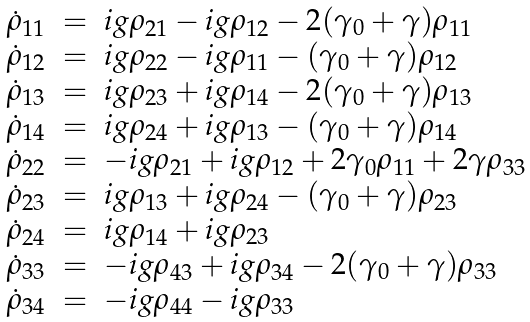<formula> <loc_0><loc_0><loc_500><loc_500>\begin{array} { c c l } \dot { \rho } _ { 1 1 } & = & i g \rho _ { 2 1 } - i g \rho _ { 1 2 } - 2 ( \gamma _ { 0 } + \gamma ) \rho _ { 1 1 } \\ \dot { \rho } _ { 1 2 } & = & i g \rho _ { 2 2 } - i g \rho _ { 1 1 } - ( \gamma _ { 0 } + \gamma ) \rho _ { 1 2 } \\ \dot { \rho } _ { 1 3 } & = & i g \rho _ { 2 3 } + i g \rho _ { 1 4 } - 2 ( \gamma _ { 0 } + \gamma ) \rho _ { 1 3 } \\ \dot { \rho } _ { 1 4 } & = & i g \rho _ { 2 4 } + i g \rho _ { 1 3 } - ( \gamma _ { 0 } + \gamma ) \rho _ { 1 4 } \\ \dot { \rho } _ { 2 2 } & = & - i g \rho _ { 2 1 } + i g \rho _ { 1 2 } + 2 \gamma _ { 0 } \rho _ { 1 1 } + 2 \gamma \rho _ { 3 3 } \\ \dot { \rho } _ { 2 3 } & = & i g \rho _ { 1 3 } + i g \rho _ { 2 4 } - ( \gamma _ { 0 } + \gamma ) \rho _ { 2 3 } \\ \dot { \rho } _ { 2 4 } & = & i g \rho _ { 1 4 } + i g \rho _ { 2 3 } \\ \dot { \rho } _ { 3 3 } & = & - i g \rho _ { 4 3 } + i g \rho _ { 3 4 } - 2 ( \gamma _ { 0 } + \gamma ) \rho _ { 3 3 } \\ \dot { \rho } _ { 3 4 } & = & - i g \rho _ { 4 4 } - i g \rho _ { 3 3 } \\ \end{array}</formula> 